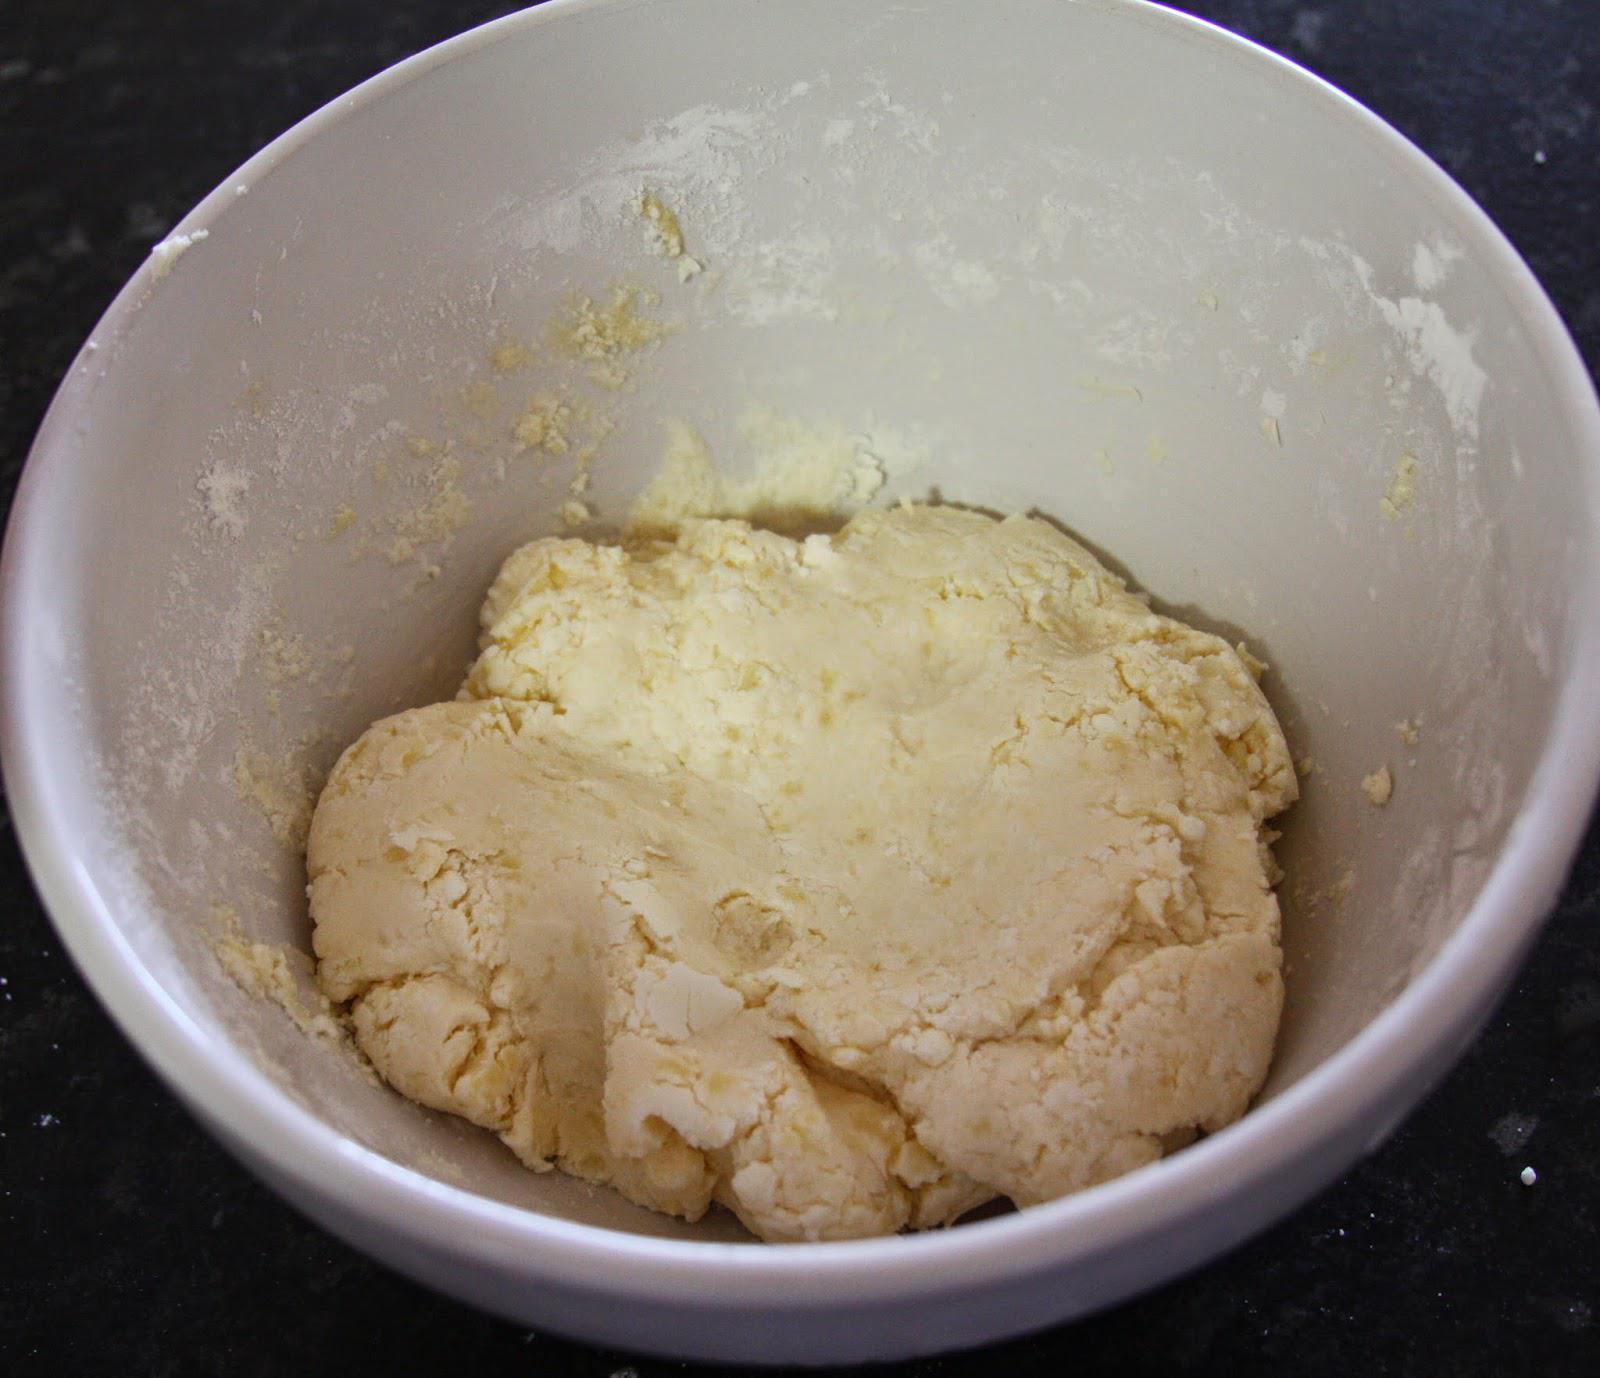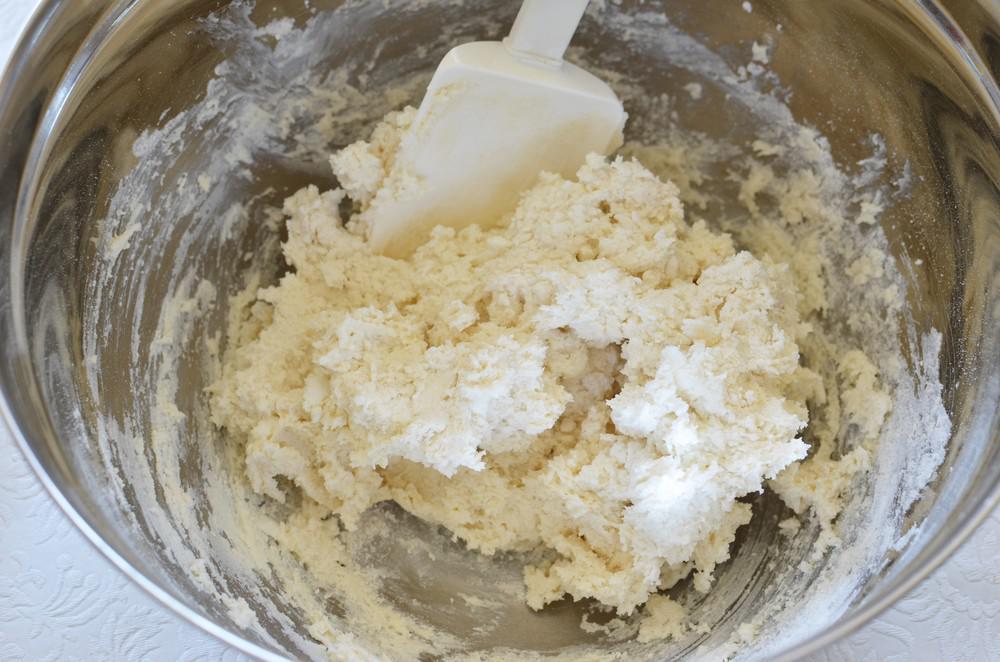The first image is the image on the left, the second image is the image on the right. Analyze the images presented: Is the assertion "The left image shows a bowl with dough in it but no utensil, and the right image shows a bowl with a utensil in the dough and its handle sticking out." valid? Answer yes or no. Yes. The first image is the image on the left, the second image is the image on the right. Given the left and right images, does the statement "There is a white bowl with dough and a silver utensil is stuck in the dough" hold true? Answer yes or no. No. 